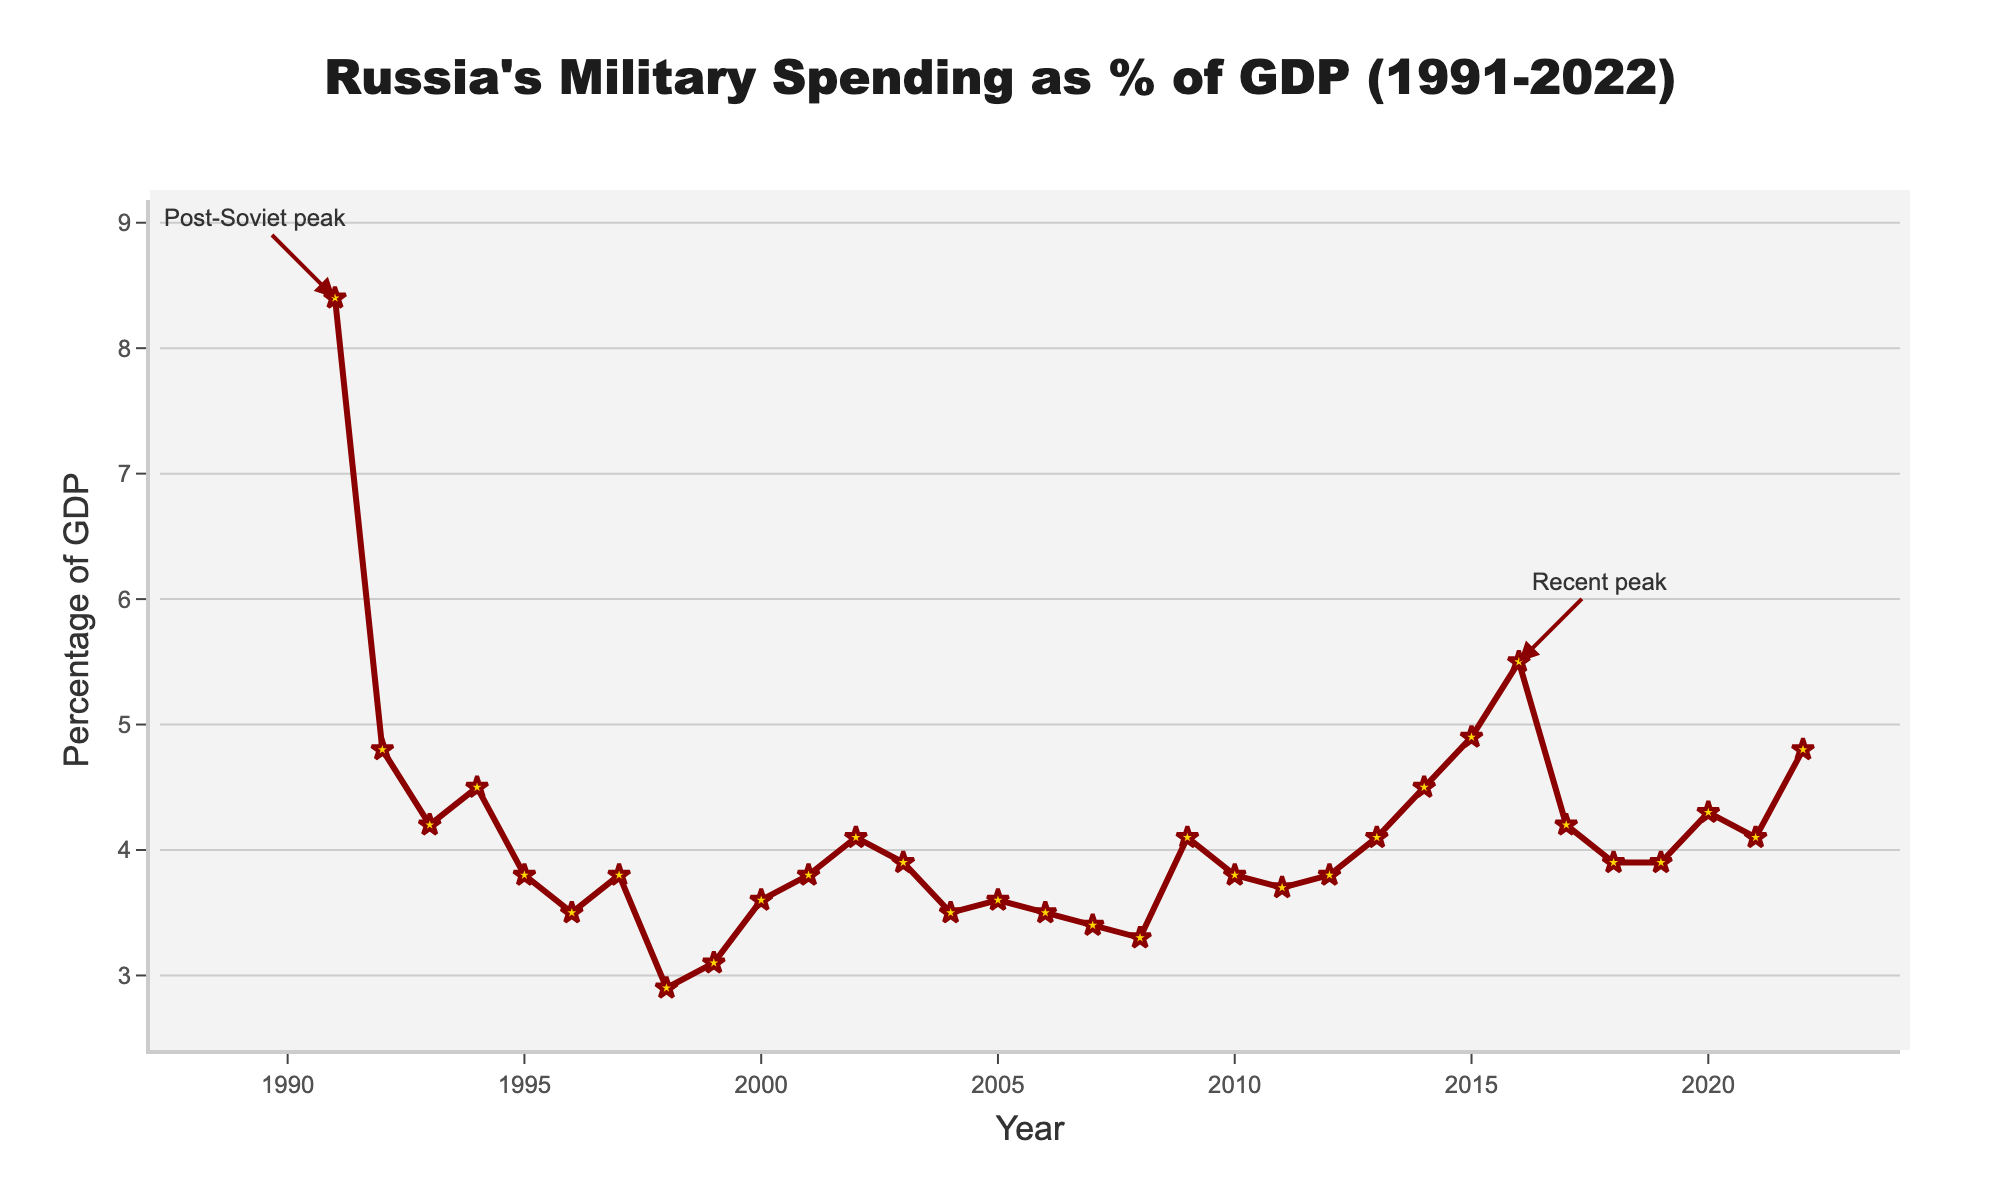How did Russia's military spending as a percentage of GDP change from 1991 to 1992? In 1991, the military spending was 8.4% of GDP, and in 1992, it dropped to 4.8%. The change is 8.4 - 4.8 = 3.6 percentage points.
Answer: It decreased by 3.6 percentage points In which year did Russia see the lowest military spending as a percentage of GDP, and what was that percentage? Looking at the figure, the lowest point is in 1998 with a percentage of 2.9%.
Answer: 1998, 2.9% Between 2008 and 2009, did Russia's military spending as a percentage of GDP increase or decrease, and by how much? The percentage increased from 3.3% in 2008 to 4.1% in 2009. The change is 4.1 - 3.3 = 0.8 percentage points.
Answer: It increased by 0.8 percentage points On average, what was Russia's military spending as a percentage of GDP during the 2010s (2010-2019)? To find the average, add the percentages for 2010 to 2019 and divide by the number of years. (3.8 + 3.7 + 3.8 + 4.1 + 4.5 + 4.9 + 5.5 + 4.2 + 3.9 + 3.9) / 10 = 42.3 / 10 = 4.23%.
Answer: 4.23% Compare the percentage of GDP spent on military in 1998 and 2016. Which year had a higher percentage, and by how much? In 1998, it was 2.9%, and in 2016, it was 5.5%. The difference is 5.5 - 2.9 = 2.6 percentage points, with 2016 being higher.
Answer: 2016 by 2.6 percentage points What visual marker is used to indicate the data points on the line chart? The figure uses star-shaped markers with a golden color and a dark red outline to indicate each data point.
Answer: Star-shaped markers What is the average percentage of GDP spent on military over the entire period (1991-2022)? Sum all the percentages provided and divide by the number of years (8.4 + 4.8 + 4.2 + 4.5 + 3.8 + 3.5 + 3.8 + 2.9 + 3.1 + 3.6 + 3.8 + 4.1 + 3.9 + 3.5 + 3.6 + 3.5 + 3.4 + 3.3 + 4.1 + 3.8 + 3.7 + 3.8 + 4.1 + 4.5 + 4.9 + 5.5 + 4.2 + 3.9 + 3.9 + 4.3 + 4.1 + 4.8) / 32 = 119.2 / 32 = 3.725%.
Answer: 3.725% What are the two peaks annotated in the figure, and in which years do they occur? The figure annotates peaks in 1991 and 2016 with the highest percentages of 8.4% and 5.5%, respectively.
Answer: 1991 and 2016 During which year did Russia's military spending as a percentage of GDP first exceed 4% after 2000? The chart shows that after 2000, the percentage exceeds 4% in 2009 for the first time, reaching 4.1%.
Answer: 2009 